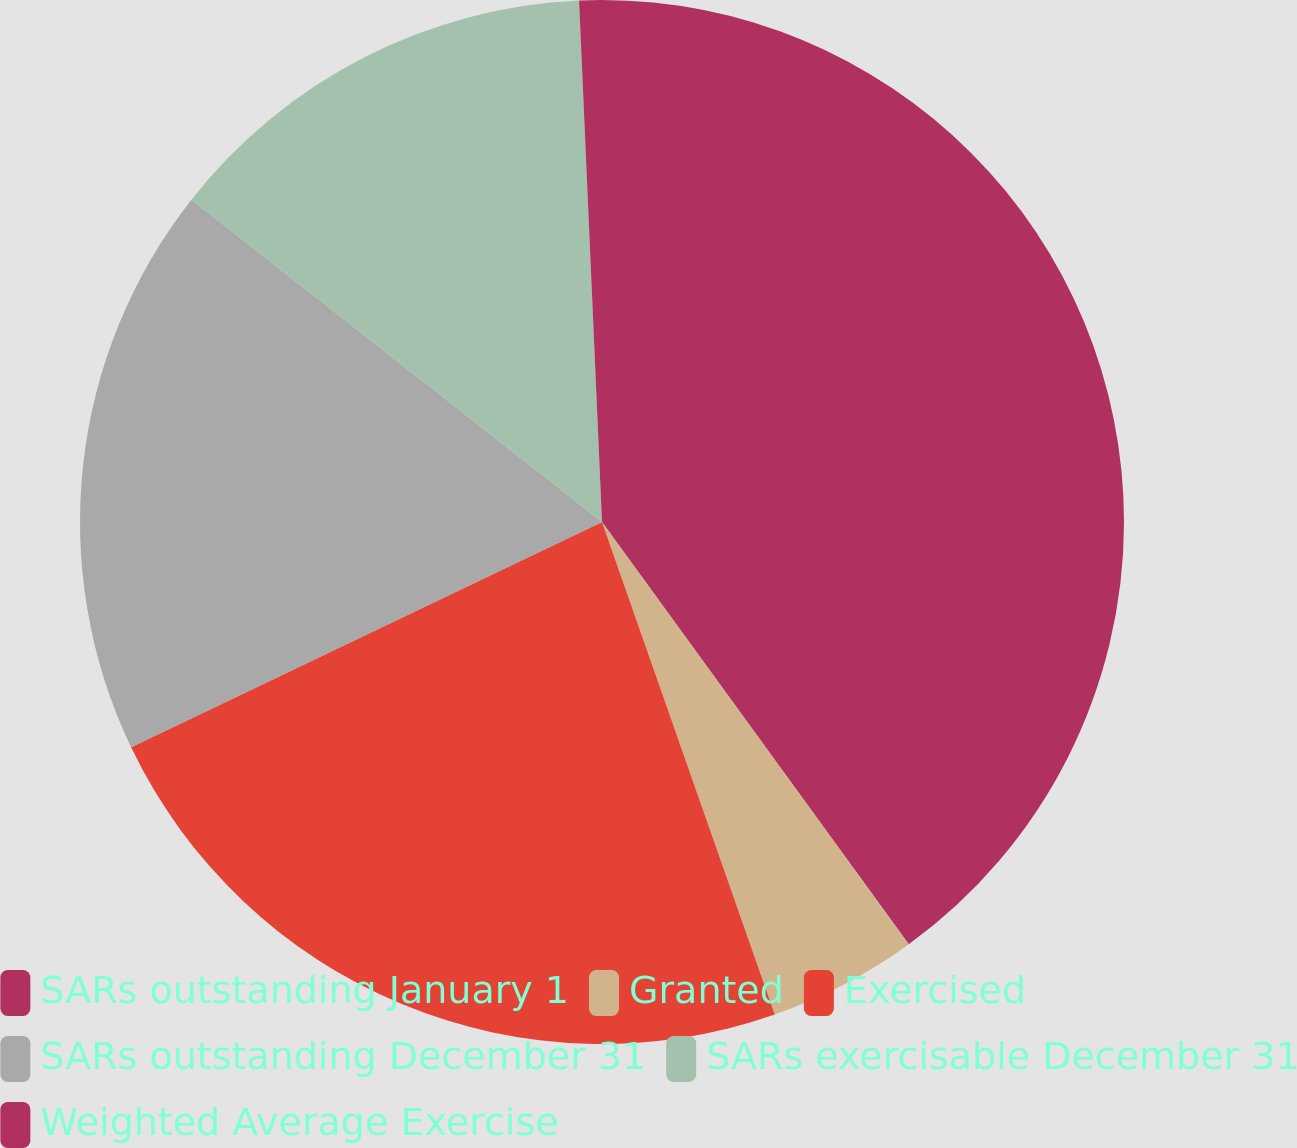<chart> <loc_0><loc_0><loc_500><loc_500><pie_chart><fcel>SARs outstanding January 1<fcel>Granted<fcel>Exercised<fcel>SARs outstanding December 31<fcel>SARs exercisable December 31<fcel>Weighted Average Exercise<nl><fcel>40.01%<fcel>4.63%<fcel>23.27%<fcel>17.7%<fcel>13.71%<fcel>0.7%<nl></chart> 